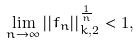Convert formula to latex. <formula><loc_0><loc_0><loc_500><loc_500>\lim _ { n \to \infty } | | f _ { n } | | _ { k , 2 } ^ { \frac { 1 } { n } } < 1 ,</formula> 